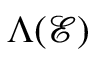Convert formula to latex. <formula><loc_0><loc_0><loc_500><loc_500>\Lambda ( \mathcal { E } )</formula> 